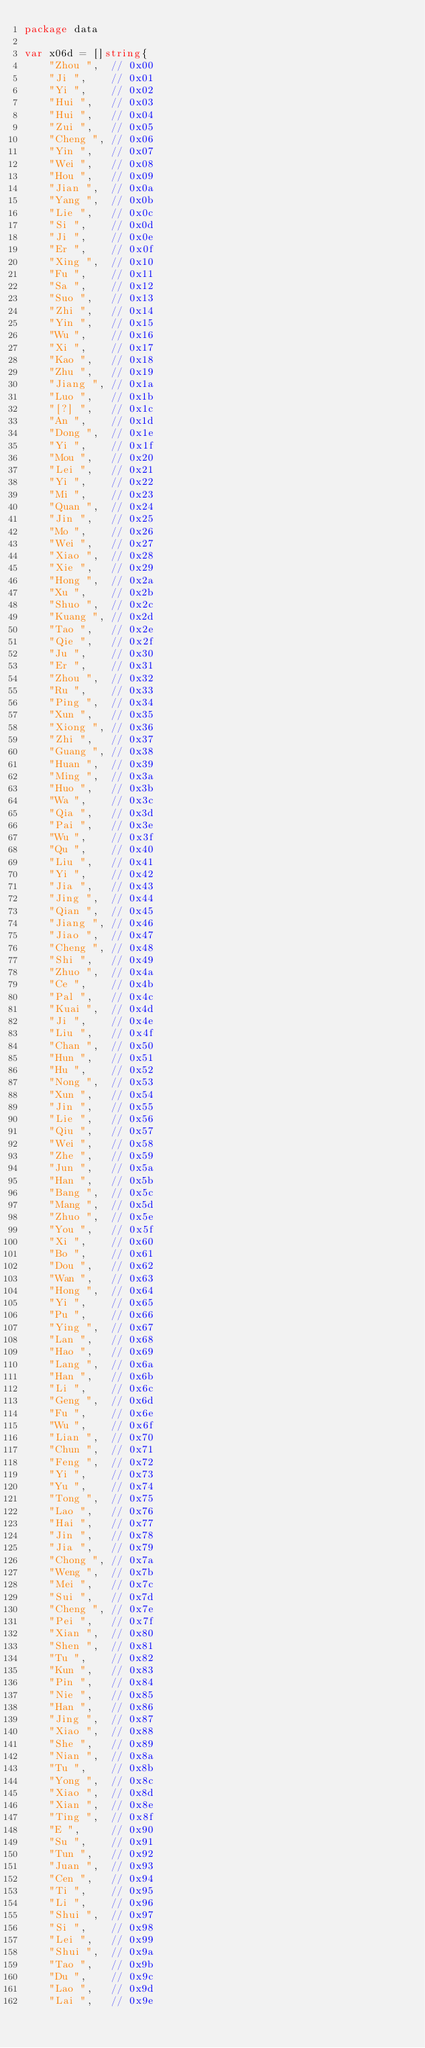<code> <loc_0><loc_0><loc_500><loc_500><_Go_>package data

var x06d = []string{
	"Zhou ",  // 0x00
	"Ji ",    // 0x01
	"Yi ",    // 0x02
	"Hui ",   // 0x03
	"Hui ",   // 0x04
	"Zui ",   // 0x05
	"Cheng ", // 0x06
	"Yin ",   // 0x07
	"Wei ",   // 0x08
	"Hou ",   // 0x09
	"Jian ",  // 0x0a
	"Yang ",  // 0x0b
	"Lie ",   // 0x0c
	"Si ",    // 0x0d
	"Ji ",    // 0x0e
	"Er ",    // 0x0f
	"Xing ",  // 0x10
	"Fu ",    // 0x11
	"Sa ",    // 0x12
	"Suo ",   // 0x13
	"Zhi ",   // 0x14
	"Yin ",   // 0x15
	"Wu ",    // 0x16
	"Xi ",    // 0x17
	"Kao ",   // 0x18
	"Zhu ",   // 0x19
	"Jiang ", // 0x1a
	"Luo ",   // 0x1b
	"[?] ",   // 0x1c
	"An ",    // 0x1d
	"Dong ",  // 0x1e
	"Yi ",    // 0x1f
	"Mou ",   // 0x20
	"Lei ",   // 0x21
	"Yi ",    // 0x22
	"Mi ",    // 0x23
	"Quan ",  // 0x24
	"Jin ",   // 0x25
	"Mo ",    // 0x26
	"Wei ",   // 0x27
	"Xiao ",  // 0x28
	"Xie ",   // 0x29
	"Hong ",  // 0x2a
	"Xu ",    // 0x2b
	"Shuo ",  // 0x2c
	"Kuang ", // 0x2d
	"Tao ",   // 0x2e
	"Qie ",   // 0x2f
	"Ju ",    // 0x30
	"Er ",    // 0x31
	"Zhou ",  // 0x32
	"Ru ",    // 0x33
	"Ping ",  // 0x34
	"Xun ",   // 0x35
	"Xiong ", // 0x36
	"Zhi ",   // 0x37
	"Guang ", // 0x38
	"Huan ",  // 0x39
	"Ming ",  // 0x3a
	"Huo ",   // 0x3b
	"Wa ",    // 0x3c
	"Qia ",   // 0x3d
	"Pai ",   // 0x3e
	"Wu ",    // 0x3f
	"Qu ",    // 0x40
	"Liu ",   // 0x41
	"Yi ",    // 0x42
	"Jia ",   // 0x43
	"Jing ",  // 0x44
	"Qian ",  // 0x45
	"Jiang ", // 0x46
	"Jiao ",  // 0x47
	"Cheng ", // 0x48
	"Shi ",   // 0x49
	"Zhuo ",  // 0x4a
	"Ce ",    // 0x4b
	"Pal ",   // 0x4c
	"Kuai ",  // 0x4d
	"Ji ",    // 0x4e
	"Liu ",   // 0x4f
	"Chan ",  // 0x50
	"Hun ",   // 0x51
	"Hu ",    // 0x52
	"Nong ",  // 0x53
	"Xun ",   // 0x54
	"Jin ",   // 0x55
	"Lie ",   // 0x56
	"Qiu ",   // 0x57
	"Wei ",   // 0x58
	"Zhe ",   // 0x59
	"Jun ",   // 0x5a
	"Han ",   // 0x5b
	"Bang ",  // 0x5c
	"Mang ",  // 0x5d
	"Zhuo ",  // 0x5e
	"You ",   // 0x5f
	"Xi ",    // 0x60
	"Bo ",    // 0x61
	"Dou ",   // 0x62
	"Wan ",   // 0x63
	"Hong ",  // 0x64
	"Yi ",    // 0x65
	"Pu ",    // 0x66
	"Ying ",  // 0x67
	"Lan ",   // 0x68
	"Hao ",   // 0x69
	"Lang ",  // 0x6a
	"Han ",   // 0x6b
	"Li ",    // 0x6c
	"Geng ",  // 0x6d
	"Fu ",    // 0x6e
	"Wu ",    // 0x6f
	"Lian ",  // 0x70
	"Chun ",  // 0x71
	"Feng ",  // 0x72
	"Yi ",    // 0x73
	"Yu ",    // 0x74
	"Tong ",  // 0x75
	"Lao ",   // 0x76
	"Hai ",   // 0x77
	"Jin ",   // 0x78
	"Jia ",   // 0x79
	"Chong ", // 0x7a
	"Weng ",  // 0x7b
	"Mei ",   // 0x7c
	"Sui ",   // 0x7d
	"Cheng ", // 0x7e
	"Pei ",   // 0x7f
	"Xian ",  // 0x80
	"Shen ",  // 0x81
	"Tu ",    // 0x82
	"Kun ",   // 0x83
	"Pin ",   // 0x84
	"Nie ",   // 0x85
	"Han ",   // 0x86
	"Jing ",  // 0x87
	"Xiao ",  // 0x88
	"She ",   // 0x89
	"Nian ",  // 0x8a
	"Tu ",    // 0x8b
	"Yong ",  // 0x8c
	"Xiao ",  // 0x8d
	"Xian ",  // 0x8e
	"Ting ",  // 0x8f
	"E ",     // 0x90
	"Su ",    // 0x91
	"Tun ",   // 0x92
	"Juan ",  // 0x93
	"Cen ",   // 0x94
	"Ti ",    // 0x95
	"Li ",    // 0x96
	"Shui ",  // 0x97
	"Si ",    // 0x98
	"Lei ",   // 0x99
	"Shui ",  // 0x9a
	"Tao ",   // 0x9b
	"Du ",    // 0x9c
	"Lao ",   // 0x9d
	"Lai ",   // 0x9e</code> 